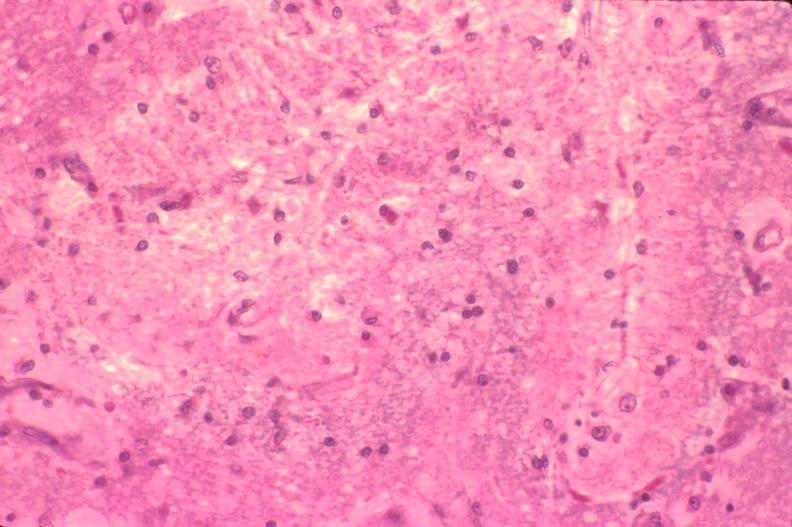does this image show brain, old infarcts, embolic?
Answer the question using a single word or phrase. Yes 